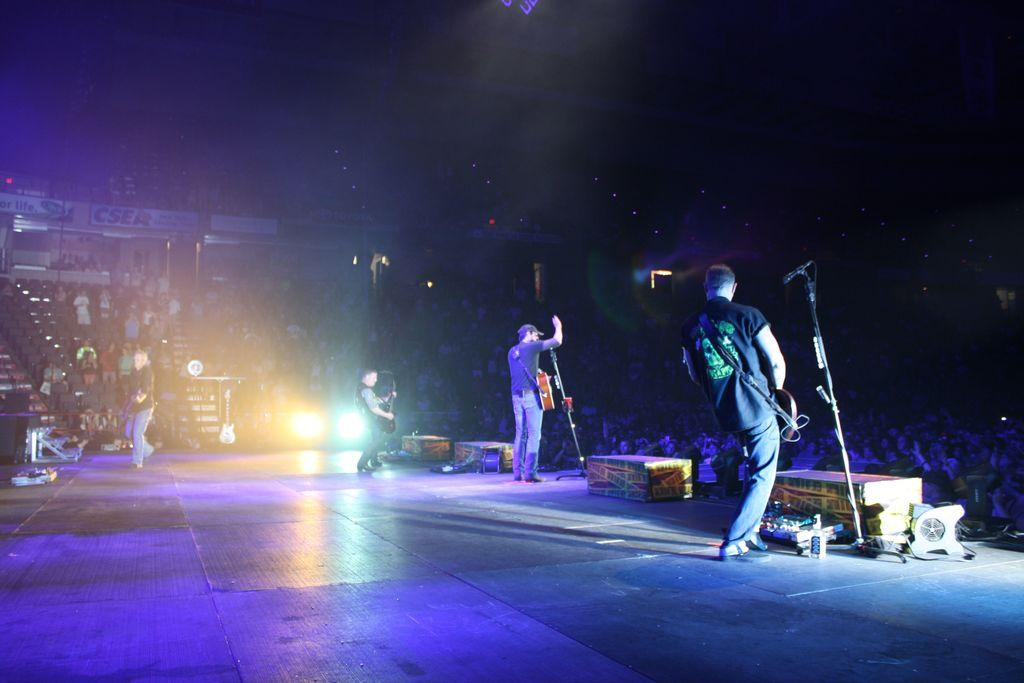How many people are on the stage in the image? There are three members on the stage in the image. What are they holding in their hands? Each member is holding a guitar. What can be seen in front of them? They are standing in front of a mic. Can you describe the audience in the image? There are people in the background watching them. What is the tax rate for the concert tickets in the image? There is no information about tax rates or concert tickets in the image; it only shows three members on stage with guitars, a mic, and people in the background watching them. 